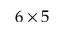<formula> <loc_0><loc_0><loc_500><loc_500>6 \times 5</formula> 